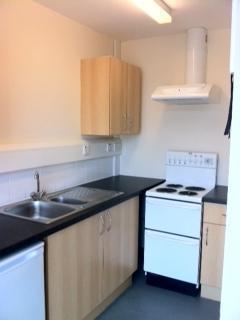How many stoves are there?
Give a very brief answer. 1. 